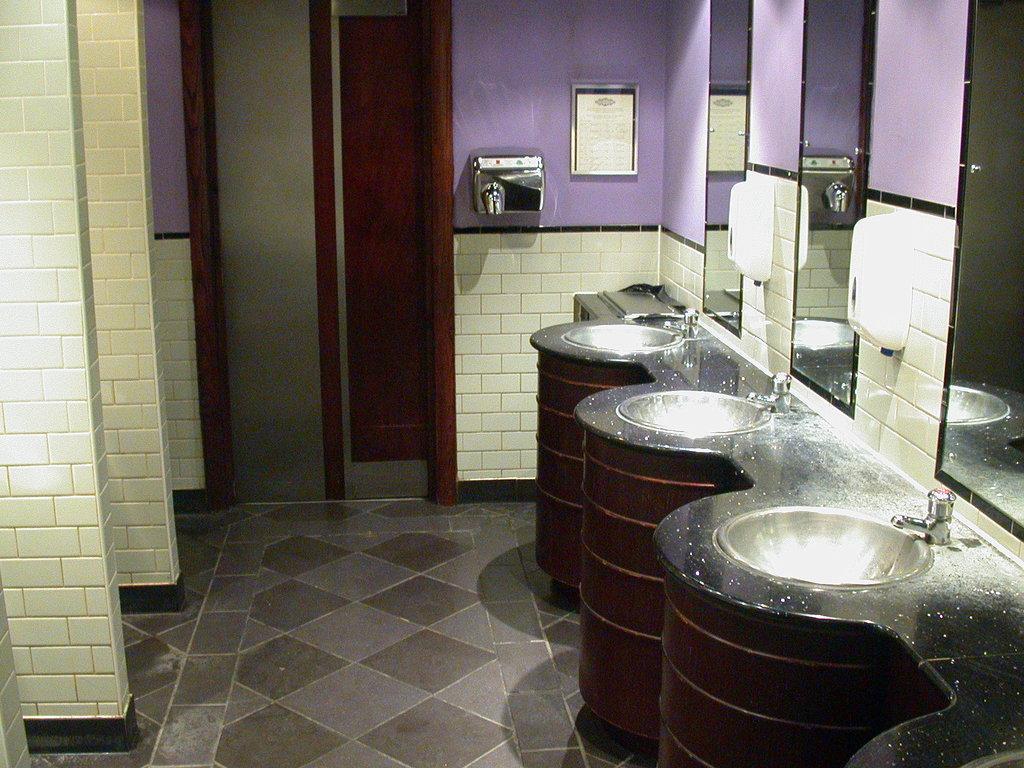Describe this image in one or two sentences. This image might be taken in restroom. In the center of the image we can see door and hand dryer. On the right side of the image we can see sinks, taps and mirrors. In the background there is wall. 